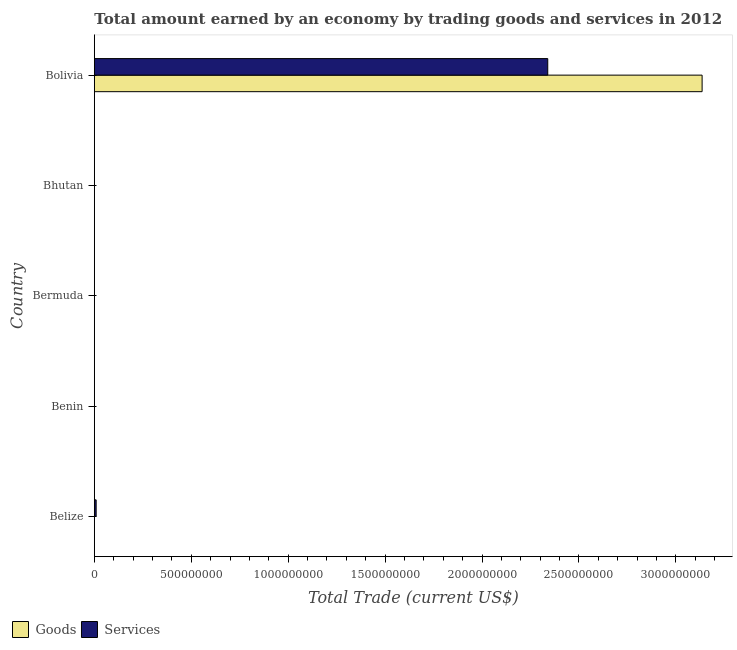How many different coloured bars are there?
Your response must be concise. 2. Are the number of bars per tick equal to the number of legend labels?
Ensure brevity in your answer.  No. What is the label of the 4th group of bars from the top?
Give a very brief answer. Benin. In how many cases, is the number of bars for a given country not equal to the number of legend labels?
Make the answer very short. 4. What is the amount earned by trading services in Bolivia?
Your answer should be compact. 2.34e+09. Across all countries, what is the maximum amount earned by trading services?
Provide a short and direct response. 2.34e+09. In which country was the amount earned by trading goods maximum?
Give a very brief answer. Bolivia. What is the total amount earned by trading goods in the graph?
Offer a terse response. 3.14e+09. What is the difference between the amount earned by trading goods in Bhutan and the amount earned by trading services in Belize?
Make the answer very short. -9.36e+06. What is the average amount earned by trading services per country?
Make the answer very short. 4.70e+08. What is the difference between the amount earned by trading services and amount earned by trading goods in Bolivia?
Keep it short and to the point. -7.96e+08. In how many countries, is the amount earned by trading goods greater than 3000000000 US$?
Offer a terse response. 1. What is the ratio of the amount earned by trading services in Belize to that in Bolivia?
Provide a short and direct response. 0. What is the difference between the highest and the lowest amount earned by trading services?
Provide a succinct answer. 2.34e+09. How many bars are there?
Give a very brief answer. 3. Are all the bars in the graph horizontal?
Your answer should be compact. Yes. How many countries are there in the graph?
Provide a succinct answer. 5. What is the difference between two consecutive major ticks on the X-axis?
Your answer should be very brief. 5.00e+08. Does the graph contain any zero values?
Offer a terse response. Yes. Where does the legend appear in the graph?
Make the answer very short. Bottom left. How many legend labels are there?
Make the answer very short. 2. What is the title of the graph?
Offer a terse response. Total amount earned by an economy by trading goods and services in 2012. What is the label or title of the X-axis?
Ensure brevity in your answer.  Total Trade (current US$). What is the label or title of the Y-axis?
Ensure brevity in your answer.  Country. What is the Total Trade (current US$) in Goods in Belize?
Ensure brevity in your answer.  0. What is the Total Trade (current US$) in Services in Belize?
Keep it short and to the point. 9.36e+06. What is the Total Trade (current US$) in Goods in Benin?
Offer a terse response. 0. What is the Total Trade (current US$) in Goods in Bermuda?
Offer a very short reply. 0. What is the Total Trade (current US$) in Goods in Bhutan?
Ensure brevity in your answer.  0. What is the Total Trade (current US$) of Goods in Bolivia?
Offer a very short reply. 3.14e+09. What is the Total Trade (current US$) of Services in Bolivia?
Provide a short and direct response. 2.34e+09. Across all countries, what is the maximum Total Trade (current US$) in Goods?
Your response must be concise. 3.14e+09. Across all countries, what is the maximum Total Trade (current US$) of Services?
Provide a short and direct response. 2.34e+09. Across all countries, what is the minimum Total Trade (current US$) in Goods?
Provide a short and direct response. 0. What is the total Total Trade (current US$) in Goods in the graph?
Keep it short and to the point. 3.14e+09. What is the total Total Trade (current US$) of Services in the graph?
Your answer should be compact. 2.35e+09. What is the difference between the Total Trade (current US$) in Services in Belize and that in Bolivia?
Offer a very short reply. -2.33e+09. What is the average Total Trade (current US$) in Goods per country?
Your response must be concise. 6.27e+08. What is the average Total Trade (current US$) in Services per country?
Make the answer very short. 4.70e+08. What is the difference between the Total Trade (current US$) in Goods and Total Trade (current US$) in Services in Bolivia?
Ensure brevity in your answer.  7.96e+08. What is the ratio of the Total Trade (current US$) in Services in Belize to that in Bolivia?
Offer a terse response. 0. What is the difference between the highest and the lowest Total Trade (current US$) of Goods?
Keep it short and to the point. 3.14e+09. What is the difference between the highest and the lowest Total Trade (current US$) of Services?
Offer a very short reply. 2.34e+09. 